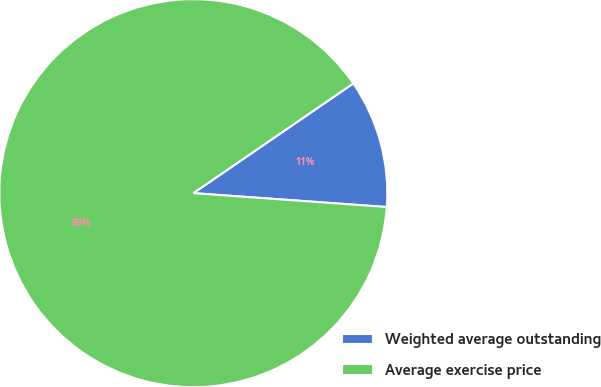Convert chart to OTSL. <chart><loc_0><loc_0><loc_500><loc_500><pie_chart><fcel>Weighted average outstanding<fcel>Average exercise price<nl><fcel>10.71%<fcel>89.29%<nl></chart> 